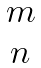Convert formula to latex. <formula><loc_0><loc_0><loc_500><loc_500>\begin{matrix} m \\ n \\ \end{matrix}</formula> 